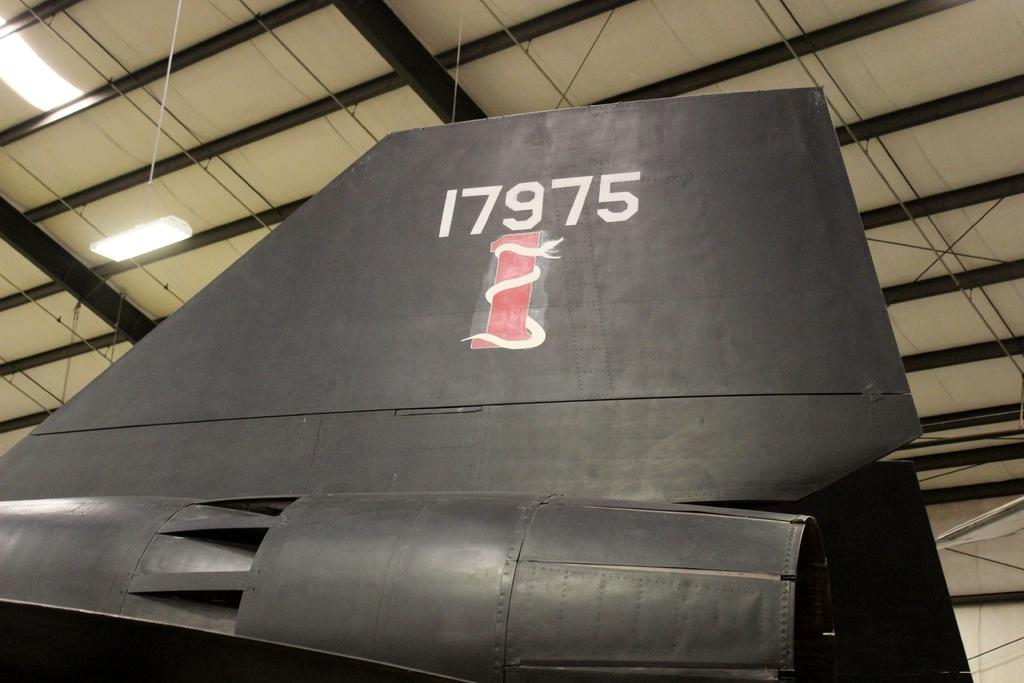<image>
Present a compact description of the photo's key features. A tail of a plane with the numbers 17975 